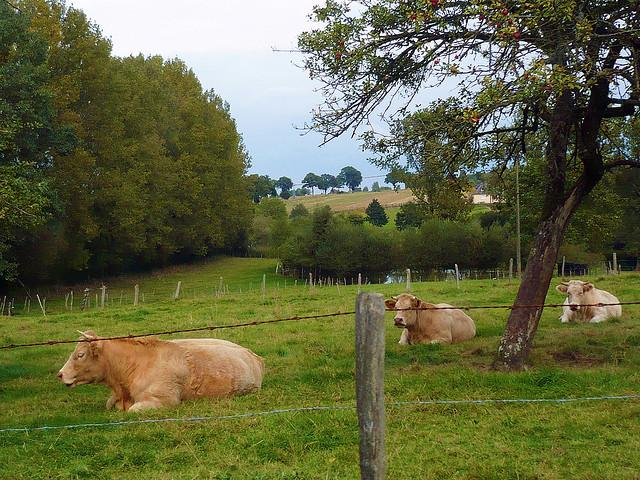What is strung on the fence to keep the cows in?

Choices:
A) wood
B) wire
C) thorns
D) metal wire 